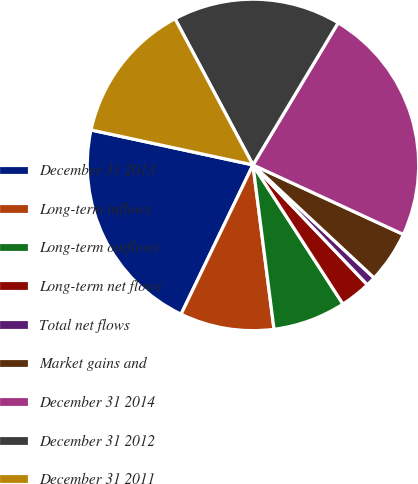<chart> <loc_0><loc_0><loc_500><loc_500><pie_chart><fcel>December 31 2013<fcel>Long-term inflows<fcel>Long-term outflows<fcel>Long-term net flows<fcel>Total net flows<fcel>Market gains and<fcel>December 31 2014<fcel>December 31 2012<fcel>December 31 2011<nl><fcel>21.24%<fcel>9.17%<fcel>7.11%<fcel>2.99%<fcel>0.93%<fcel>5.05%<fcel>23.3%<fcel>16.39%<fcel>13.82%<nl></chart> 